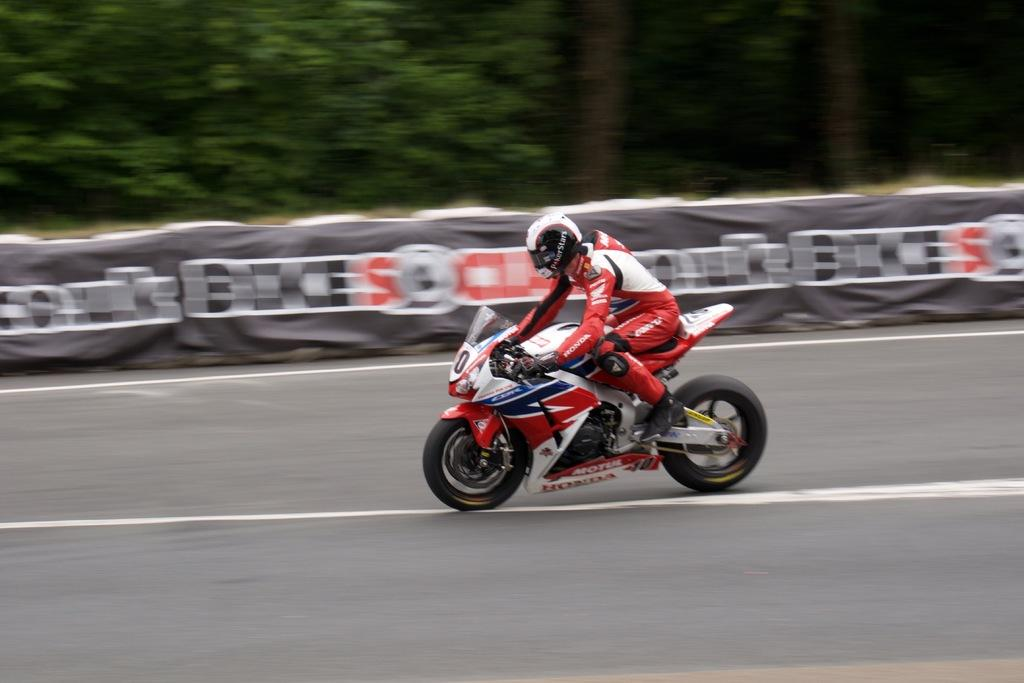What is the main subject of the image? There is a person riding a bike on the road. Can you describe the road in the image? The road is visible at the bottom of the image. What can be seen in the background of the image? There is a wall in the background of the image. What type of vegetation is visible at the top of the image? There are trees at the top of the image. What type of scarf is the person wearing while riding the bike in the image? There is no scarf visible in the image; the person is riding a bike on the road. How does the zipper on the person's jacket affect their ability to ride the bike in the image? There is no mention of a jacket or zipper in the image; the person is simply riding a bike on the road. 